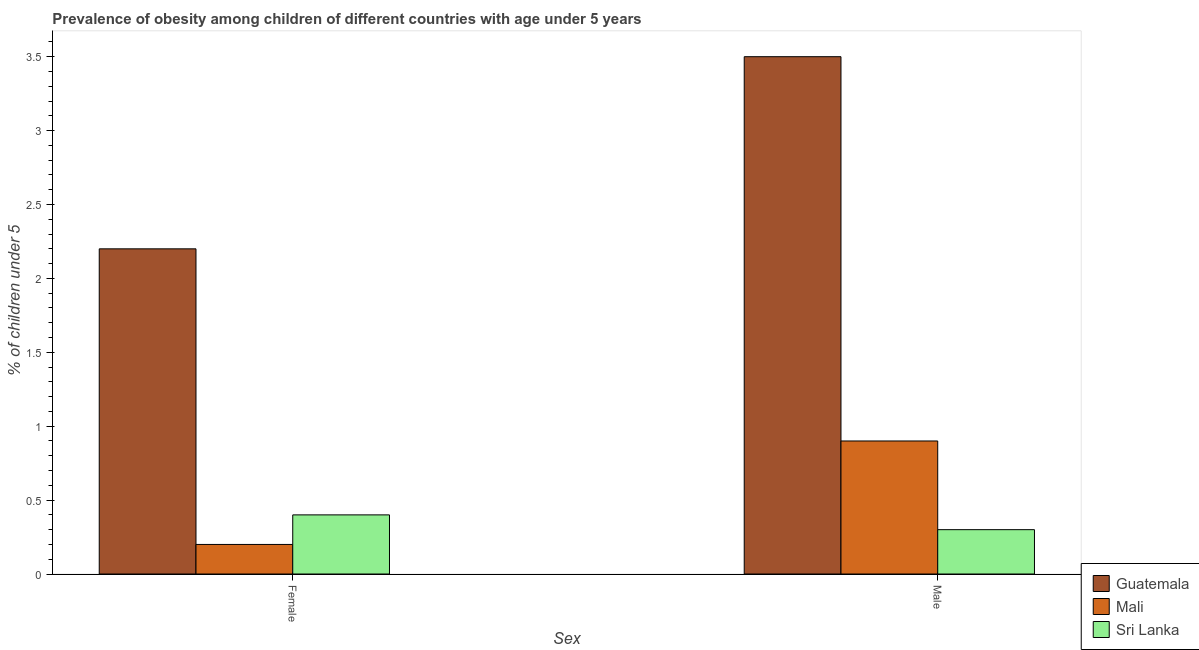How many groups of bars are there?
Your answer should be very brief. 2. How many bars are there on the 2nd tick from the right?
Keep it short and to the point. 3. What is the percentage of obese male children in Sri Lanka?
Give a very brief answer. 0.3. Across all countries, what is the minimum percentage of obese female children?
Your answer should be compact. 0.2. In which country was the percentage of obese female children maximum?
Offer a terse response. Guatemala. In which country was the percentage of obese female children minimum?
Your response must be concise. Mali. What is the total percentage of obese female children in the graph?
Your answer should be compact. 2.8. What is the difference between the percentage of obese male children in Guatemala and that in Mali?
Your answer should be very brief. 2.6. What is the difference between the percentage of obese male children in Guatemala and the percentage of obese female children in Sri Lanka?
Your response must be concise. 3.1. What is the average percentage of obese female children per country?
Your response must be concise. 0.93. What is the difference between the percentage of obese female children and percentage of obese male children in Sri Lanka?
Your response must be concise. 0.1. In how many countries, is the percentage of obese male children greater than 1.8 %?
Your response must be concise. 1. What is the ratio of the percentage of obese male children in Mali to that in Sri Lanka?
Make the answer very short. 3. What does the 1st bar from the left in Female represents?
Offer a terse response. Guatemala. What does the 1st bar from the right in Male represents?
Keep it short and to the point. Sri Lanka. Are all the bars in the graph horizontal?
Make the answer very short. No. How many countries are there in the graph?
Your response must be concise. 3. Are the values on the major ticks of Y-axis written in scientific E-notation?
Offer a terse response. No. Does the graph contain grids?
Your answer should be compact. No. How many legend labels are there?
Provide a short and direct response. 3. How are the legend labels stacked?
Give a very brief answer. Vertical. What is the title of the graph?
Give a very brief answer. Prevalence of obesity among children of different countries with age under 5 years. What is the label or title of the X-axis?
Your answer should be very brief. Sex. What is the label or title of the Y-axis?
Give a very brief answer.  % of children under 5. What is the  % of children under 5 in Guatemala in Female?
Your answer should be very brief. 2.2. What is the  % of children under 5 of Mali in Female?
Your answer should be compact. 0.2. What is the  % of children under 5 in Sri Lanka in Female?
Your response must be concise. 0.4. What is the  % of children under 5 of Guatemala in Male?
Provide a succinct answer. 3.5. What is the  % of children under 5 in Mali in Male?
Your answer should be compact. 0.9. What is the  % of children under 5 of Sri Lanka in Male?
Offer a terse response. 0.3. Across all Sex, what is the maximum  % of children under 5 in Mali?
Your response must be concise. 0.9. Across all Sex, what is the maximum  % of children under 5 of Sri Lanka?
Provide a succinct answer. 0.4. Across all Sex, what is the minimum  % of children under 5 of Guatemala?
Offer a terse response. 2.2. Across all Sex, what is the minimum  % of children under 5 in Mali?
Give a very brief answer. 0.2. Across all Sex, what is the minimum  % of children under 5 of Sri Lanka?
Give a very brief answer. 0.3. What is the total  % of children under 5 of Mali in the graph?
Provide a short and direct response. 1.1. What is the difference between the  % of children under 5 of Guatemala in Female and that in Male?
Your response must be concise. -1.3. What is the difference between the  % of children under 5 of Mali in Female and that in Male?
Your answer should be very brief. -0.7. What is the difference between the  % of children under 5 of Sri Lanka in Female and that in Male?
Provide a succinct answer. 0.1. What is the average  % of children under 5 in Guatemala per Sex?
Offer a very short reply. 2.85. What is the average  % of children under 5 of Mali per Sex?
Make the answer very short. 0.55. What is the average  % of children under 5 in Sri Lanka per Sex?
Provide a short and direct response. 0.35. What is the difference between the  % of children under 5 of Mali and  % of children under 5 of Sri Lanka in Female?
Provide a short and direct response. -0.2. What is the ratio of the  % of children under 5 in Guatemala in Female to that in Male?
Offer a terse response. 0.63. What is the ratio of the  % of children under 5 of Mali in Female to that in Male?
Offer a terse response. 0.22. What is the ratio of the  % of children under 5 of Sri Lanka in Female to that in Male?
Your response must be concise. 1.33. What is the difference between the highest and the second highest  % of children under 5 of Guatemala?
Make the answer very short. 1.3. What is the difference between the highest and the second highest  % of children under 5 in Sri Lanka?
Offer a terse response. 0.1. What is the difference between the highest and the lowest  % of children under 5 in Sri Lanka?
Your answer should be very brief. 0.1. 